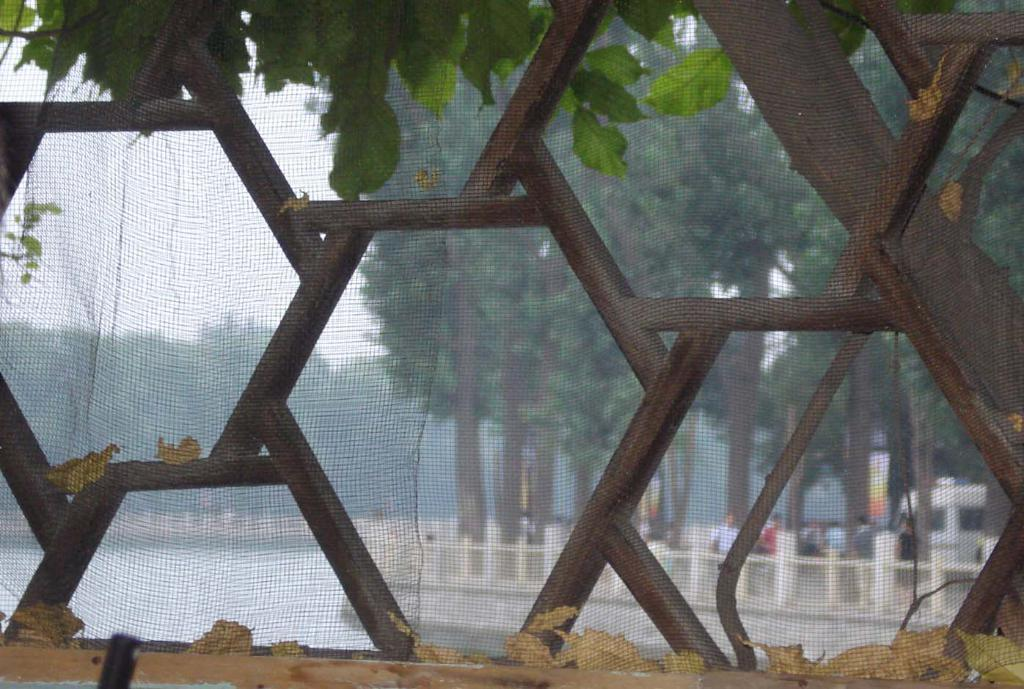What is the primary purpose of the net with a grill in the image? The net with a grill provides a view of the other side. What can be seen through the net? Trees, water, rod fencing, people, and the sky are visible through the net. Can you describe the view on the other side of the net? The view on the other side of the net includes trees, water, and rod fencing. Are there any people visible through the net? Yes, there are people visible through the net. What type of sound can be heard coming from the net in the image? There is no sound coming from the net in the image; it is a visual element only. 